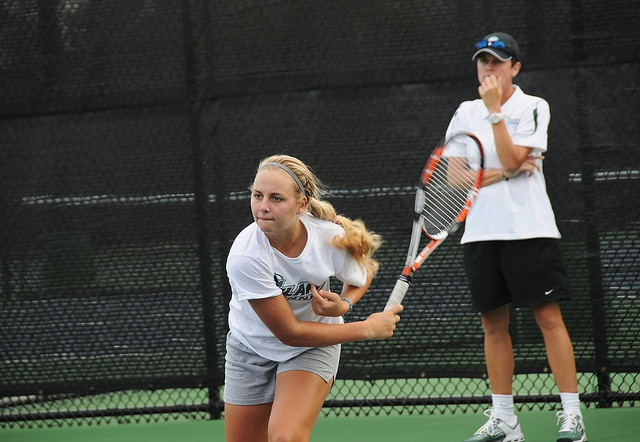Describe the objects in this image and their specific colors. I can see people in black, lightgray, darkgray, gray, and tan tones, people in black, lightgray, gray, and brown tones, and tennis racket in black, lightgray, gray, and darkgray tones in this image. 